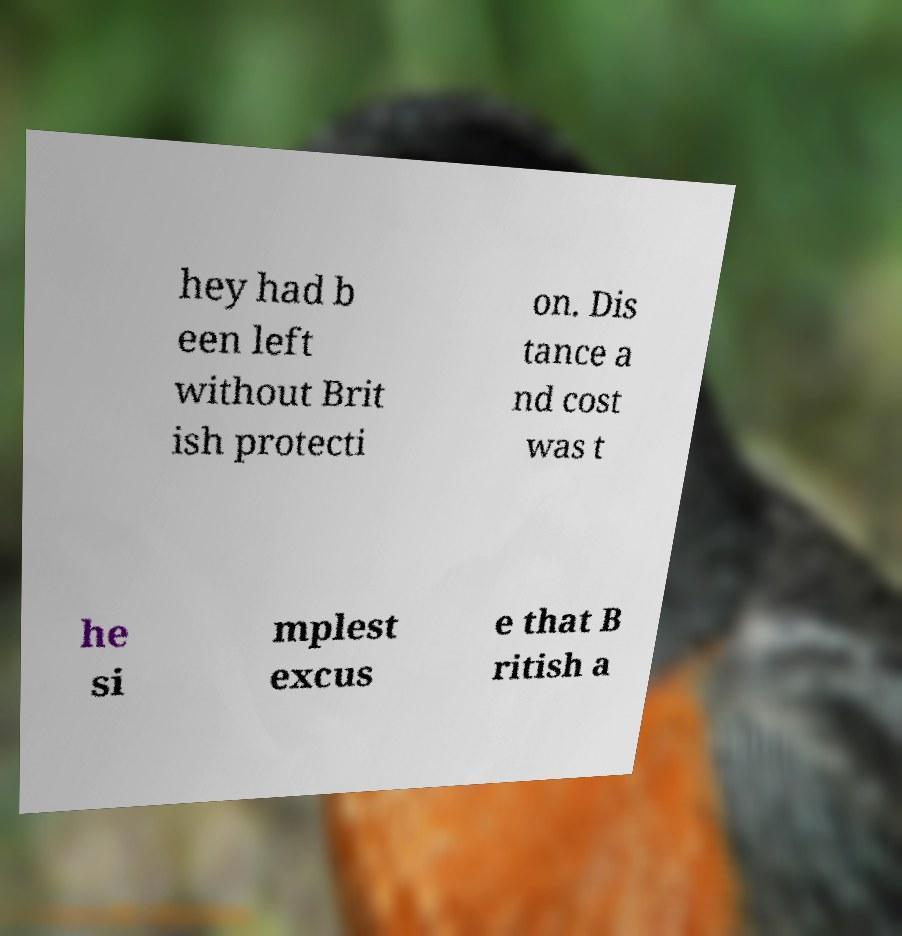I need the written content from this picture converted into text. Can you do that? hey had b een left without Brit ish protecti on. Dis tance a nd cost was t he si mplest excus e that B ritish a 